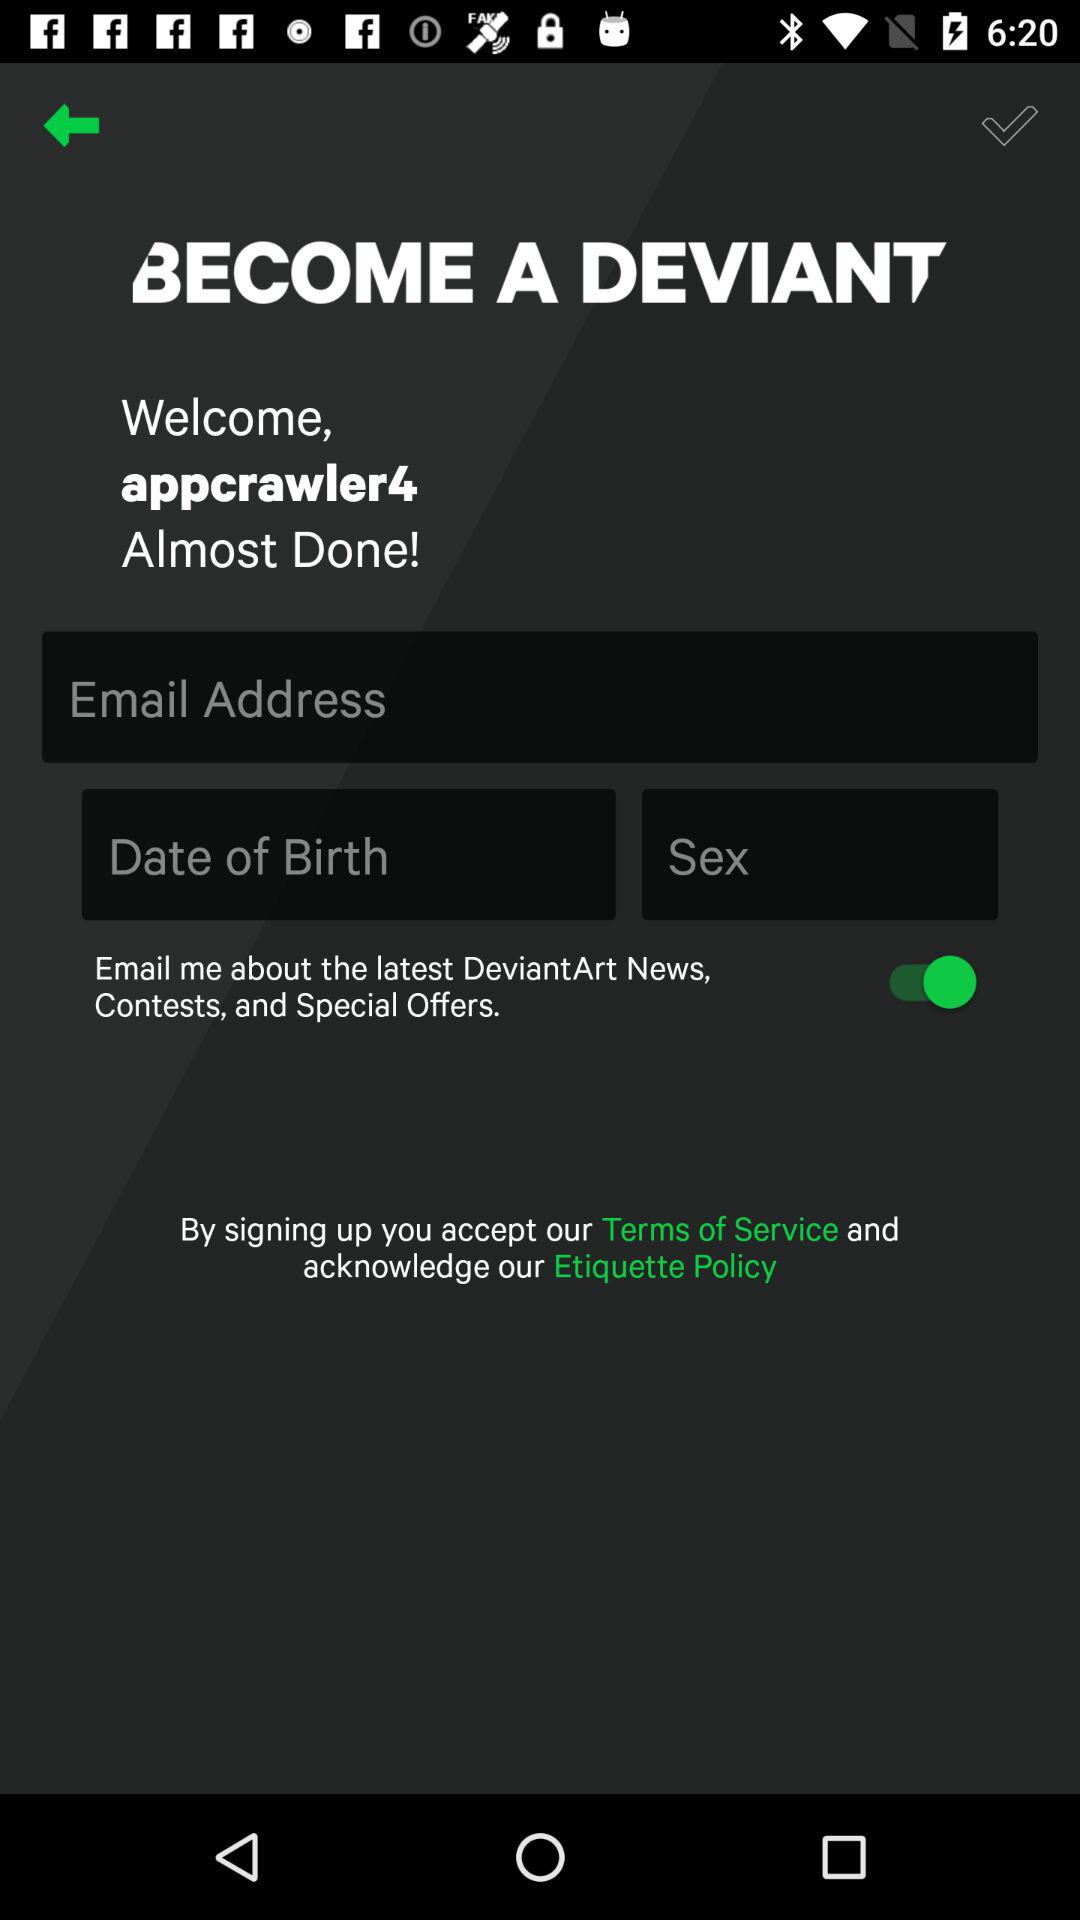How many text fields are there to complete the sign up process?
Answer the question using a single word or phrase. 3 